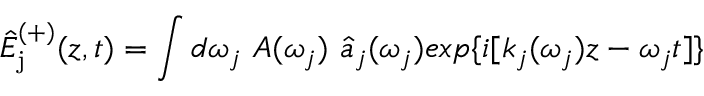<formula> <loc_0><loc_0><loc_500><loc_500>\hat { E } _ { j } ^ { ( + ) } ( z , t ) = \int d \omega _ { j } A ( \omega _ { j } ) \hat { a } _ { j } ( \omega _ { j } ) e x p \{ i [ k _ { j } ( \omega _ { j } ) z - \omega _ { j } t ] \}</formula> 